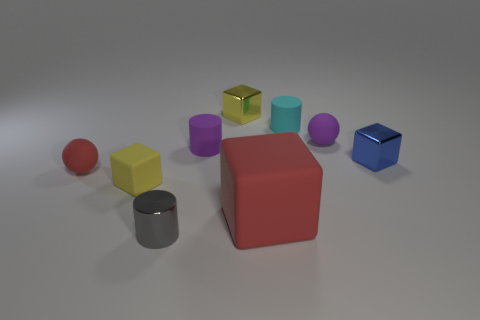There is a object that is the same color as the big cube; what is its shape?
Your response must be concise. Sphere. What number of things are either tiny yellow objects that are behind the blue block or red things?
Offer a terse response. 3. Do the cyan matte cylinder and the red block have the same size?
Your response must be concise. No. What is the color of the matte cube in front of the yellow matte object?
Your answer should be compact. Red. There is a yellow object that is the same material as the cyan object; what size is it?
Make the answer very short. Small. Do the blue metal cube and the matte cylinder that is behind the tiny purple ball have the same size?
Make the answer very short. Yes. There is a sphere that is right of the small gray metallic thing; what material is it?
Give a very brief answer. Rubber. There is a yellow block that is in front of the small purple rubber sphere; how many small matte objects are behind it?
Ensure brevity in your answer.  4. Are there any tiny gray metallic objects of the same shape as the tiny cyan thing?
Ensure brevity in your answer.  Yes. There is a red object in front of the small yellow matte block; does it have the same size as the cyan rubber thing that is behind the red cube?
Your response must be concise. No. 